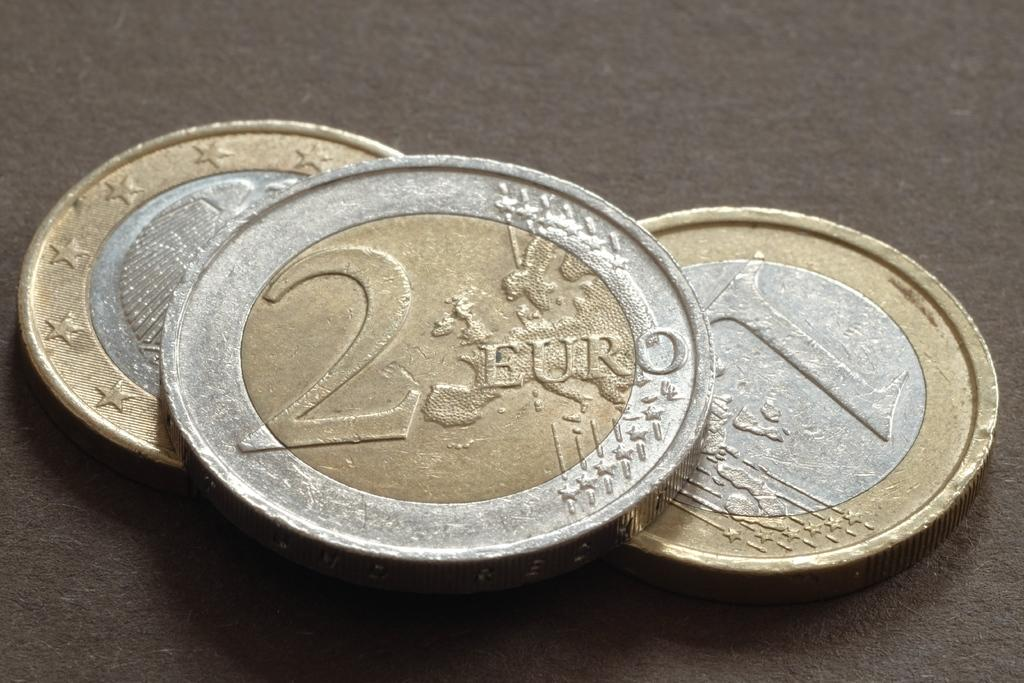<image>
Present a compact description of the photo's key features. Silver and gold coins with 2 EURO printed on the top coin. 